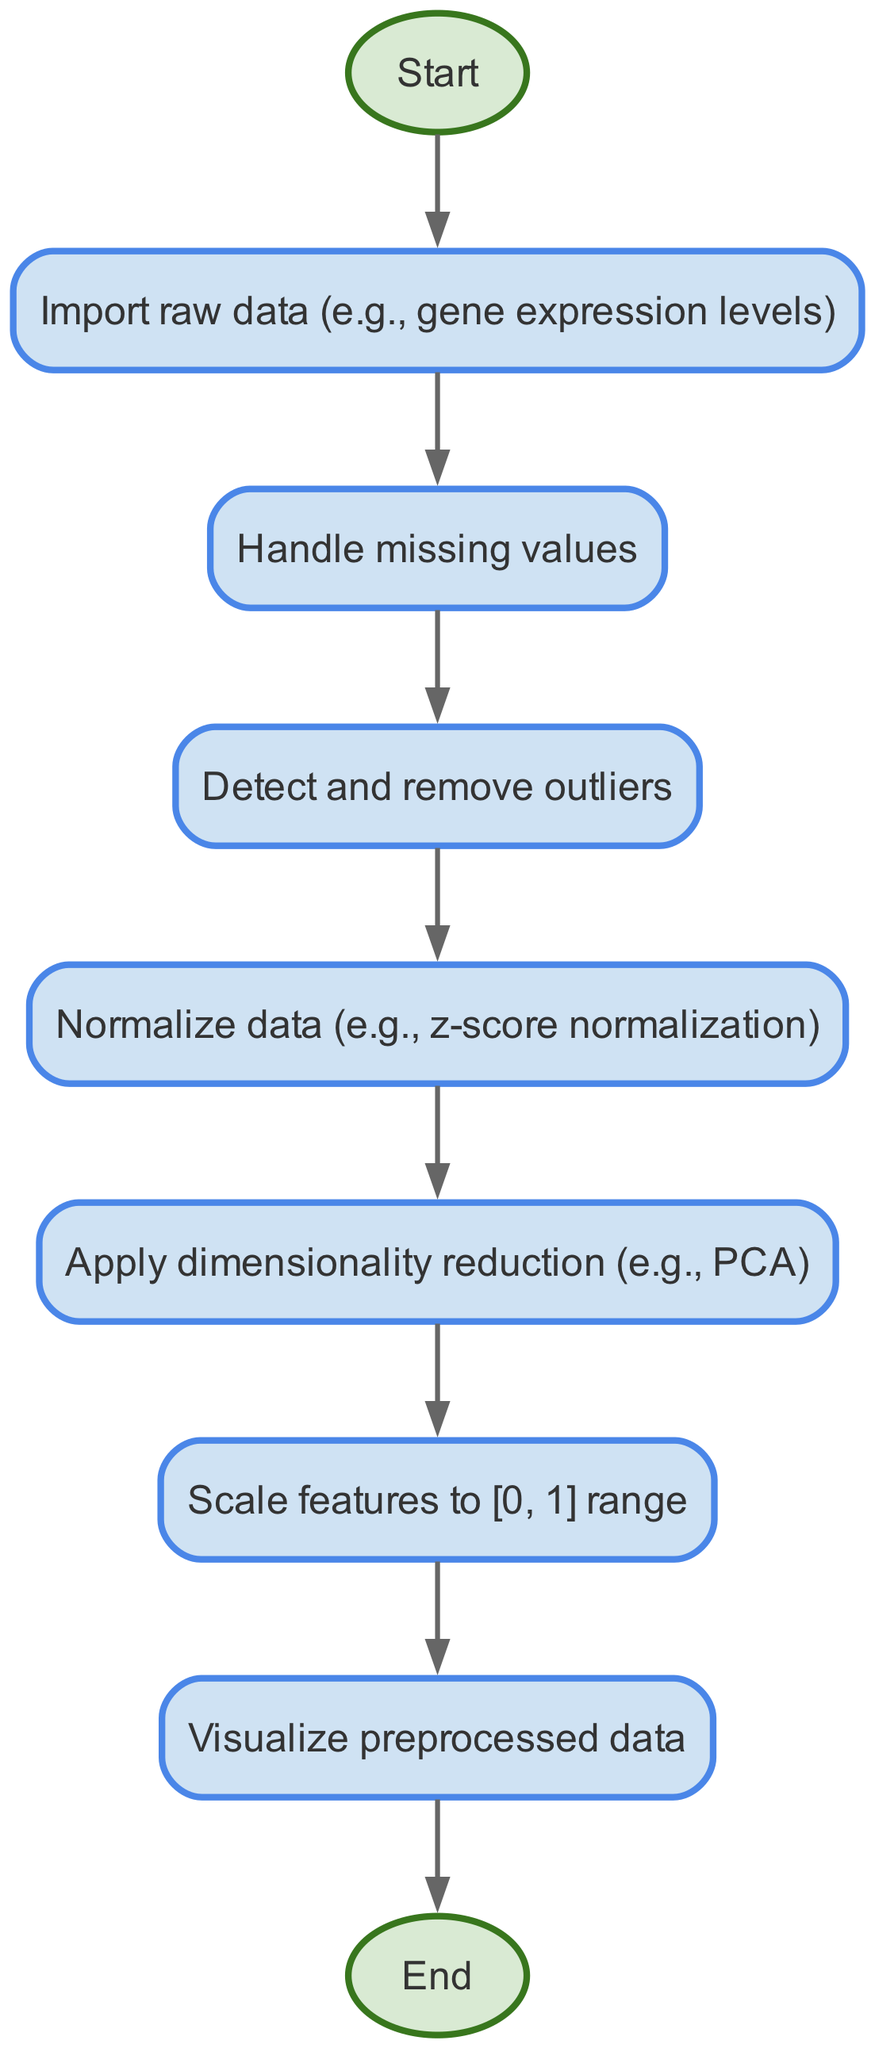What is the first step in the data preprocessing flow chart? The first step in the flow chart is labeled "Start," which indicates the initiation of the data preprocessing process. After that, the next node is "Import raw data." Therefore, the first action taken is to start the process.
Answer: Start How many nodes are present in the flow chart? The flow chart contains a total of eight nodes. These include "Start," "Import raw data," "Handle missing values," "Detect and remove outliers," "Normalize data," "Apply dimensionality reduction," "Scale features to [0, 1] range," and "Visualize preprocessed data," followed by "End."
Answer: Eight Which step follows the "Handle missing values" node? After the "Handle missing values" node in the diagram, the next step indicated is "Detect and remove outliers." This shows a clear sequential flow in the data preprocessing process.
Answer: Detect and remove outliers In the preprocessing steps, what is done immediately after normalization? According to the flow chart, after the normalization step, the next action taken is to "Apply dimensionality reduction." This indicates that normalization is necessary before dimensionality reduction can be applied.
Answer: Apply dimensionality reduction What is the relationship between the "Normalize data" and "Scale features to [0, 1] range" nodes? The relationship between these two nodes shows that "Normalize data" is a step that must be completed before moving on to "Scale features to [0, 1] range." This means normalization is a prerequisite for scaling in the preprocessing workflow.
Answer: Normalize data is before Scale features Which step is the last in the data preprocessing flow? The last step in the flow chart is "End," which signifies the conclusion of the data preprocessing process after all steps have been completed.
Answer: End What type of technique is applied in the dimensionality reduction step? The flow chart suggests that for dimensionality reduction, a specific approach mentioned is PCA (Principal Component Analysis). This technique is commonly used to reduce the dimensionality of data while preserving as much variance as possible.
Answer: PCA If missing values are not handled, which step could be affected in the flow? If missing values are not handled properly, it could directly impact the "Detect and remove outliers" step, as the presence of missing values may lead to incorrect outlier detection results. Hence, handling missing values is critical in maintaining data integrity for subsequent analysis.
Answer: Detect and remove outliers What color indicates the start and end nodes in the flow chart? The start and end nodes in the flow chart are indicated by a light green color, specifically "#d9ead3." This visual distinction helps to easily identify the initiation and conclusion of the flow chart process.
Answer: Light green 